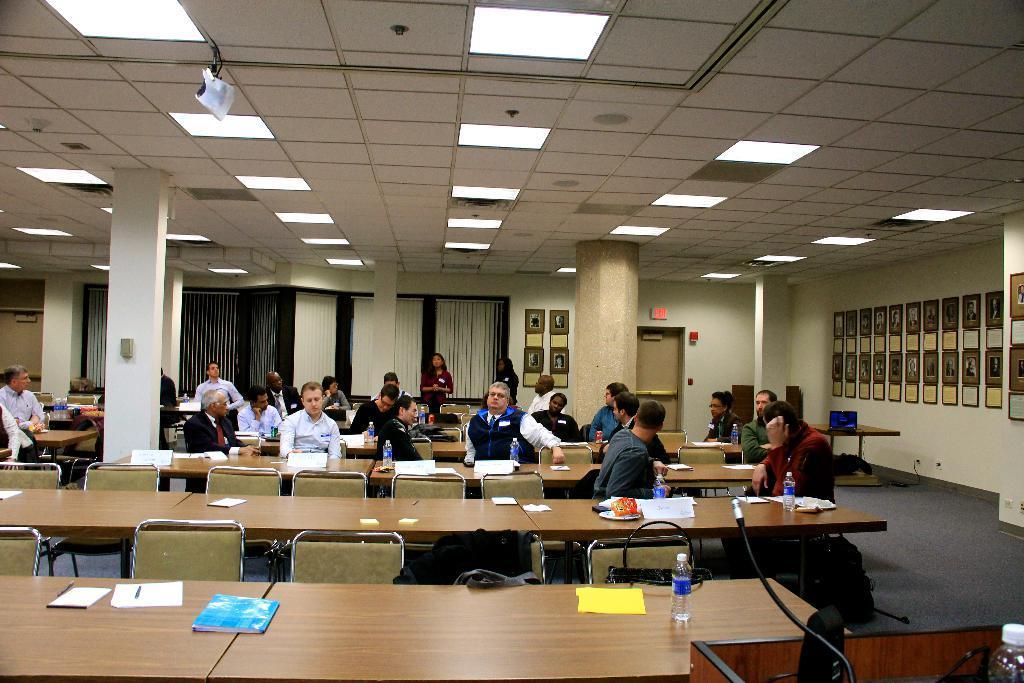Could you give a brief overview of what you see in this image? Lights are attached to ceiling. Different type of pictures on wall. Most of the persons are sitting on chairs. Far these two women are standing. In-front of this person's there are table, on this tablet there is a bottle, book, paper and pen. On this table there is a speaker and mic. Far on this table there is a laptop. On floor there are bags. 